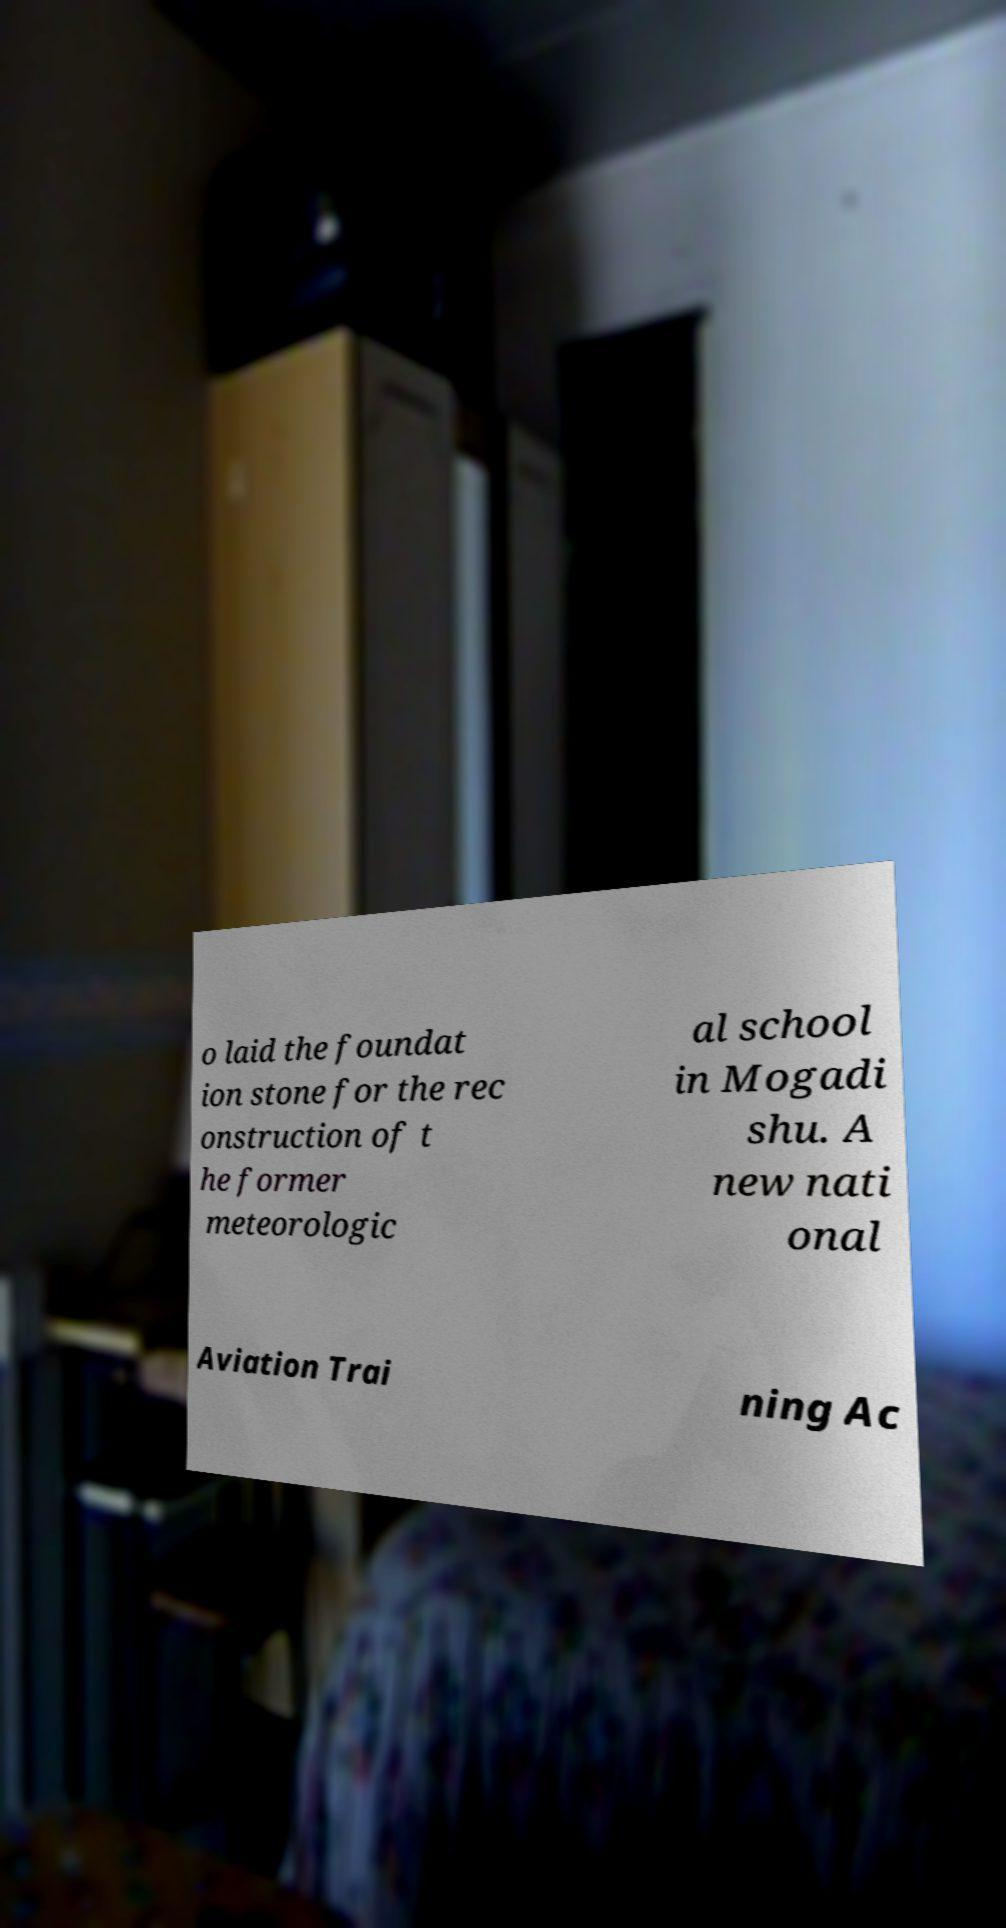Can you accurately transcribe the text from the provided image for me? o laid the foundat ion stone for the rec onstruction of t he former meteorologic al school in Mogadi shu. A new nati onal Aviation Trai ning Ac 